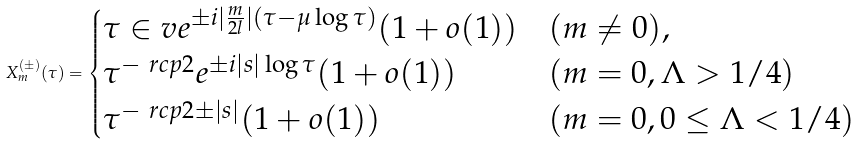<formula> <loc_0><loc_0><loc_500><loc_500>X _ { m } ^ { ( \pm ) } ( \tau ) = \begin{cases} { \tau \in v } e ^ { \pm i | \frac { m } { 2 l } | ( \tau - \mu \log \tau ) } ( 1 + o ( 1 ) ) & ( m \neq 0 ) , \\ { \tau ^ { - \ r c p 2 } } e ^ { \pm i | s | \log \tau } ( 1 + o ( 1 ) ) & ( m = 0 , \Lambda > 1 / 4 ) \\ \tau ^ { - \ r c p 2 \pm | s | } ( 1 + o ( 1 ) ) & ( m = 0 , 0 \leq \Lambda < 1 / 4 ) \end{cases}</formula> 